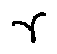Convert formula to latex. <formula><loc_0><loc_0><loc_500><loc_500>\gamma</formula> 